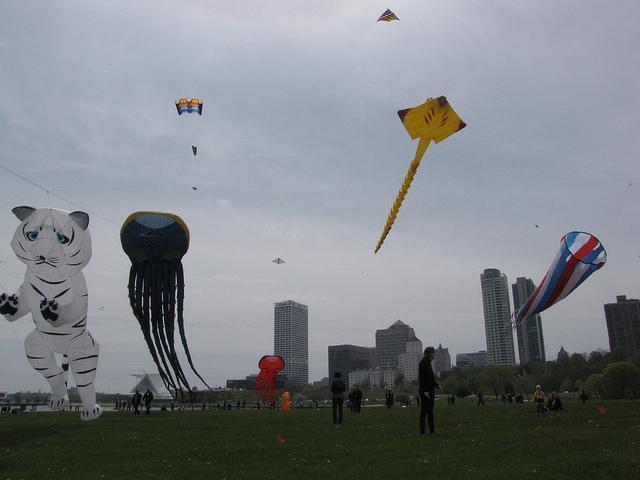How many kites can you see?
Give a very brief answer. 4. 